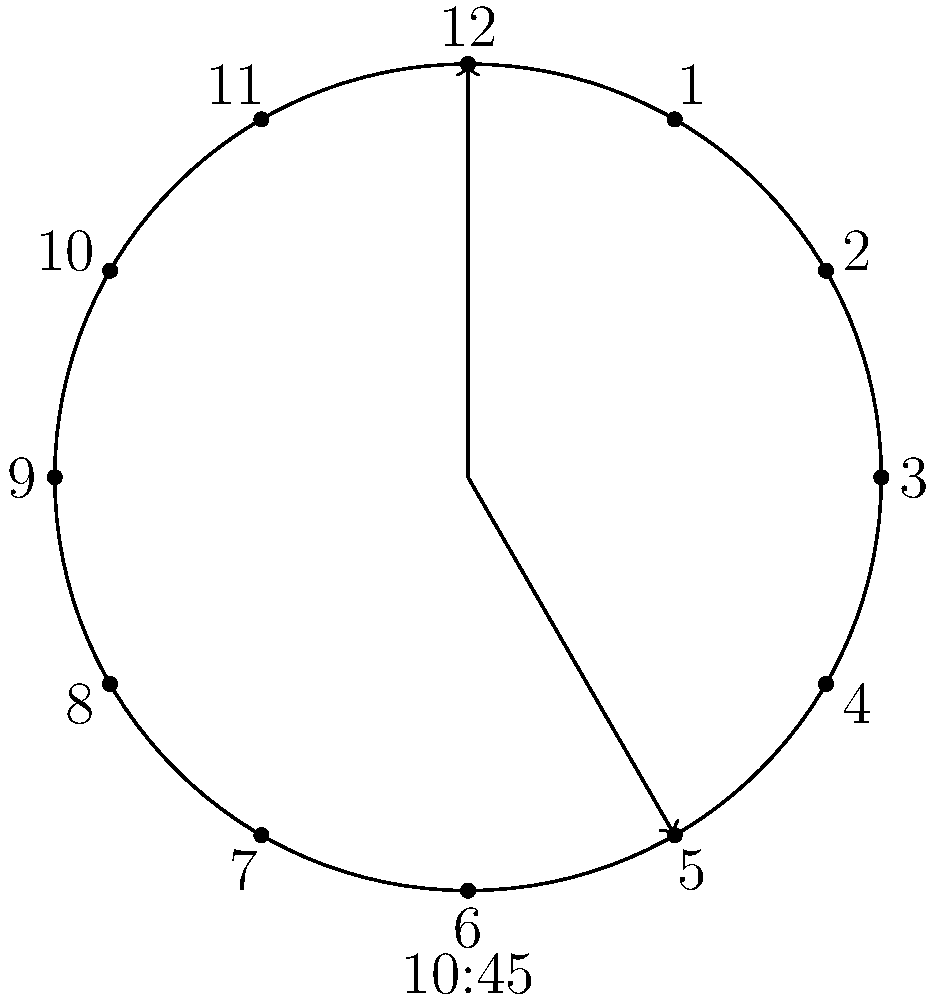During a typical Sunday service that starts at 10:45 AM, what is the angle formed by the hour and minute hands of the clock? To calculate the angle between the hour and minute hands at 10:45 AM, we'll follow these steps:

1. Calculate the angle of the hour hand:
   - In 12 hours, the hour hand rotates 360°
   - In 1 hour, it rotates 360° ÷ 12 = 30°
   - At 10:45, it's 10 hours plus 3/4 of an hour past 12
   - Angle of hour hand = (10 + 3/4) × 30° = 322.5°

2. Calculate the angle of the minute hand:
   - In 60 minutes, the minute hand rotates 360°
   - In 1 minute, it rotates 360° ÷ 60 = 6°
   - At 45 minutes past the hour, it rotates 45 × 6° = 270°

3. Calculate the difference between these angles:
   $$|322.5° - 270°| = 52.5°$$

4. If the difference is greater than 180°, subtract it from 360° to get the smaller angle:
   52.5° is less than 180°, so no need to adjust.

Therefore, the angle between the hour and minute hands at 10:45 AM is 52.5°.
Answer: $52.5°$ 